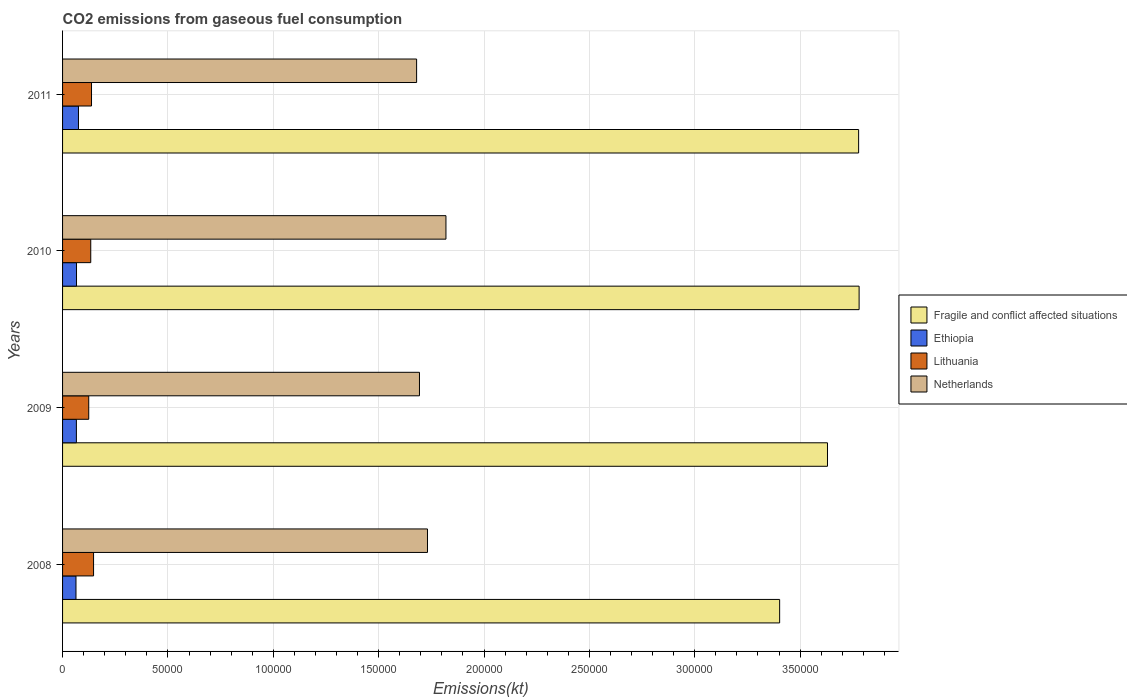How many groups of bars are there?
Offer a very short reply. 4. How many bars are there on the 2nd tick from the bottom?
Give a very brief answer. 4. What is the label of the 2nd group of bars from the top?
Provide a succinct answer. 2010. What is the amount of CO2 emitted in Fragile and conflict affected situations in 2010?
Ensure brevity in your answer.  3.78e+05. Across all years, what is the maximum amount of CO2 emitted in Lithuania?
Provide a succinct answer. 1.47e+04. Across all years, what is the minimum amount of CO2 emitted in Netherlands?
Ensure brevity in your answer.  1.68e+05. What is the total amount of CO2 emitted in Fragile and conflict affected situations in the graph?
Provide a short and direct response. 1.46e+06. What is the difference between the amount of CO2 emitted in Lithuania in 2010 and that in 2011?
Offer a terse response. -363.03. What is the difference between the amount of CO2 emitted in Ethiopia in 2009 and the amount of CO2 emitted in Lithuania in 2011?
Your answer should be very brief. -7179.99. What is the average amount of CO2 emitted in Ethiopia per year?
Make the answer very short. 6772.95. In the year 2011, what is the difference between the amount of CO2 emitted in Netherlands and amount of CO2 emitted in Fragile and conflict affected situations?
Give a very brief answer. -2.10e+05. What is the ratio of the amount of CO2 emitted in Lithuania in 2009 to that in 2011?
Give a very brief answer. 0.9. What is the difference between the highest and the second highest amount of CO2 emitted in Lithuania?
Offer a terse response. 968.09. What is the difference between the highest and the lowest amount of CO2 emitted in Fragile and conflict affected situations?
Keep it short and to the point. 3.77e+04. What does the 3rd bar from the top in 2010 represents?
Give a very brief answer. Ethiopia. Are all the bars in the graph horizontal?
Keep it short and to the point. Yes. Are the values on the major ticks of X-axis written in scientific E-notation?
Your response must be concise. No. Does the graph contain any zero values?
Offer a terse response. No. Does the graph contain grids?
Offer a very short reply. Yes. How many legend labels are there?
Ensure brevity in your answer.  4. How are the legend labels stacked?
Provide a short and direct response. Vertical. What is the title of the graph?
Keep it short and to the point. CO2 emissions from gaseous fuel consumption. Does "New Caledonia" appear as one of the legend labels in the graph?
Give a very brief answer. No. What is the label or title of the X-axis?
Keep it short and to the point. Emissions(kt). What is the Emissions(kt) of Fragile and conflict affected situations in 2008?
Provide a succinct answer. 3.40e+05. What is the Emissions(kt) in Ethiopia in 2008?
Your answer should be compact. 6369.58. What is the Emissions(kt) in Lithuania in 2008?
Provide a succinct answer. 1.47e+04. What is the Emissions(kt) in Netherlands in 2008?
Offer a terse response. 1.73e+05. What is the Emissions(kt) of Fragile and conflict affected situations in 2009?
Provide a succinct answer. 3.63e+05. What is the Emissions(kt) in Ethiopia in 2009?
Your answer should be very brief. 6560.26. What is the Emissions(kt) in Lithuania in 2009?
Ensure brevity in your answer.  1.24e+04. What is the Emissions(kt) in Netherlands in 2009?
Keep it short and to the point. 1.69e+05. What is the Emissions(kt) of Fragile and conflict affected situations in 2010?
Offer a very short reply. 3.78e+05. What is the Emissions(kt) of Ethiopia in 2010?
Ensure brevity in your answer.  6618.94. What is the Emissions(kt) in Lithuania in 2010?
Offer a very short reply. 1.34e+04. What is the Emissions(kt) in Netherlands in 2010?
Make the answer very short. 1.82e+05. What is the Emissions(kt) of Fragile and conflict affected situations in 2011?
Your answer should be very brief. 3.78e+05. What is the Emissions(kt) of Ethiopia in 2011?
Provide a succinct answer. 7543.02. What is the Emissions(kt) in Lithuania in 2011?
Ensure brevity in your answer.  1.37e+04. What is the Emissions(kt) of Netherlands in 2011?
Give a very brief answer. 1.68e+05. Across all years, what is the maximum Emissions(kt) in Fragile and conflict affected situations?
Provide a short and direct response. 3.78e+05. Across all years, what is the maximum Emissions(kt) in Ethiopia?
Your response must be concise. 7543.02. Across all years, what is the maximum Emissions(kt) of Lithuania?
Offer a terse response. 1.47e+04. Across all years, what is the maximum Emissions(kt) in Netherlands?
Ensure brevity in your answer.  1.82e+05. Across all years, what is the minimum Emissions(kt) of Fragile and conflict affected situations?
Ensure brevity in your answer.  3.40e+05. Across all years, what is the minimum Emissions(kt) in Ethiopia?
Your response must be concise. 6369.58. Across all years, what is the minimum Emissions(kt) in Lithuania?
Offer a terse response. 1.24e+04. Across all years, what is the minimum Emissions(kt) in Netherlands?
Keep it short and to the point. 1.68e+05. What is the total Emissions(kt) in Fragile and conflict affected situations in the graph?
Give a very brief answer. 1.46e+06. What is the total Emissions(kt) in Ethiopia in the graph?
Your response must be concise. 2.71e+04. What is the total Emissions(kt) in Lithuania in the graph?
Keep it short and to the point. 5.42e+04. What is the total Emissions(kt) in Netherlands in the graph?
Your answer should be compact. 6.92e+05. What is the difference between the Emissions(kt) in Fragile and conflict affected situations in 2008 and that in 2009?
Give a very brief answer. -2.27e+04. What is the difference between the Emissions(kt) of Ethiopia in 2008 and that in 2009?
Provide a succinct answer. -190.68. What is the difference between the Emissions(kt) in Lithuania in 2008 and that in 2009?
Your answer should be very brief. 2291.88. What is the difference between the Emissions(kt) in Netherlands in 2008 and that in 2009?
Provide a succinct answer. 3799.01. What is the difference between the Emissions(kt) of Fragile and conflict affected situations in 2008 and that in 2010?
Your answer should be very brief. -3.77e+04. What is the difference between the Emissions(kt) of Ethiopia in 2008 and that in 2010?
Offer a very short reply. -249.36. What is the difference between the Emissions(kt) in Lithuania in 2008 and that in 2010?
Your response must be concise. 1331.12. What is the difference between the Emissions(kt) in Netherlands in 2008 and that in 2010?
Give a very brief answer. -8764.13. What is the difference between the Emissions(kt) in Fragile and conflict affected situations in 2008 and that in 2011?
Ensure brevity in your answer.  -3.75e+04. What is the difference between the Emissions(kt) in Ethiopia in 2008 and that in 2011?
Provide a short and direct response. -1173.44. What is the difference between the Emissions(kt) of Lithuania in 2008 and that in 2011?
Make the answer very short. 968.09. What is the difference between the Emissions(kt) of Netherlands in 2008 and that in 2011?
Keep it short and to the point. 5155.8. What is the difference between the Emissions(kt) in Fragile and conflict affected situations in 2009 and that in 2010?
Give a very brief answer. -1.50e+04. What is the difference between the Emissions(kt) in Ethiopia in 2009 and that in 2010?
Ensure brevity in your answer.  -58.67. What is the difference between the Emissions(kt) in Lithuania in 2009 and that in 2010?
Give a very brief answer. -960.75. What is the difference between the Emissions(kt) of Netherlands in 2009 and that in 2010?
Ensure brevity in your answer.  -1.26e+04. What is the difference between the Emissions(kt) in Fragile and conflict affected situations in 2009 and that in 2011?
Ensure brevity in your answer.  -1.48e+04. What is the difference between the Emissions(kt) of Ethiopia in 2009 and that in 2011?
Give a very brief answer. -982.76. What is the difference between the Emissions(kt) in Lithuania in 2009 and that in 2011?
Provide a succinct answer. -1323.79. What is the difference between the Emissions(kt) of Netherlands in 2009 and that in 2011?
Offer a very short reply. 1356.79. What is the difference between the Emissions(kt) of Fragile and conflict affected situations in 2010 and that in 2011?
Offer a very short reply. 227.42. What is the difference between the Emissions(kt) in Ethiopia in 2010 and that in 2011?
Provide a succinct answer. -924.08. What is the difference between the Emissions(kt) of Lithuania in 2010 and that in 2011?
Your answer should be compact. -363.03. What is the difference between the Emissions(kt) of Netherlands in 2010 and that in 2011?
Make the answer very short. 1.39e+04. What is the difference between the Emissions(kt) of Fragile and conflict affected situations in 2008 and the Emissions(kt) of Ethiopia in 2009?
Ensure brevity in your answer.  3.34e+05. What is the difference between the Emissions(kt) in Fragile and conflict affected situations in 2008 and the Emissions(kt) in Lithuania in 2009?
Give a very brief answer. 3.28e+05. What is the difference between the Emissions(kt) in Fragile and conflict affected situations in 2008 and the Emissions(kt) in Netherlands in 2009?
Make the answer very short. 1.71e+05. What is the difference between the Emissions(kt) in Ethiopia in 2008 and the Emissions(kt) in Lithuania in 2009?
Provide a succinct answer. -6046.88. What is the difference between the Emissions(kt) of Ethiopia in 2008 and the Emissions(kt) of Netherlands in 2009?
Keep it short and to the point. -1.63e+05. What is the difference between the Emissions(kt) of Lithuania in 2008 and the Emissions(kt) of Netherlands in 2009?
Provide a succinct answer. -1.55e+05. What is the difference between the Emissions(kt) in Fragile and conflict affected situations in 2008 and the Emissions(kt) in Ethiopia in 2010?
Keep it short and to the point. 3.34e+05. What is the difference between the Emissions(kt) in Fragile and conflict affected situations in 2008 and the Emissions(kt) in Lithuania in 2010?
Make the answer very short. 3.27e+05. What is the difference between the Emissions(kt) of Fragile and conflict affected situations in 2008 and the Emissions(kt) of Netherlands in 2010?
Give a very brief answer. 1.58e+05. What is the difference between the Emissions(kt) in Ethiopia in 2008 and the Emissions(kt) in Lithuania in 2010?
Make the answer very short. -7007.64. What is the difference between the Emissions(kt) in Ethiopia in 2008 and the Emissions(kt) in Netherlands in 2010?
Provide a succinct answer. -1.76e+05. What is the difference between the Emissions(kt) of Lithuania in 2008 and the Emissions(kt) of Netherlands in 2010?
Give a very brief answer. -1.67e+05. What is the difference between the Emissions(kt) in Fragile and conflict affected situations in 2008 and the Emissions(kt) in Ethiopia in 2011?
Offer a terse response. 3.33e+05. What is the difference between the Emissions(kt) in Fragile and conflict affected situations in 2008 and the Emissions(kt) in Lithuania in 2011?
Provide a short and direct response. 3.27e+05. What is the difference between the Emissions(kt) in Fragile and conflict affected situations in 2008 and the Emissions(kt) in Netherlands in 2011?
Make the answer very short. 1.72e+05. What is the difference between the Emissions(kt) of Ethiopia in 2008 and the Emissions(kt) of Lithuania in 2011?
Keep it short and to the point. -7370.67. What is the difference between the Emissions(kt) in Ethiopia in 2008 and the Emissions(kt) in Netherlands in 2011?
Provide a short and direct response. -1.62e+05. What is the difference between the Emissions(kt) in Lithuania in 2008 and the Emissions(kt) in Netherlands in 2011?
Provide a short and direct response. -1.53e+05. What is the difference between the Emissions(kt) in Fragile and conflict affected situations in 2009 and the Emissions(kt) in Ethiopia in 2010?
Give a very brief answer. 3.56e+05. What is the difference between the Emissions(kt) in Fragile and conflict affected situations in 2009 and the Emissions(kt) in Lithuania in 2010?
Your answer should be compact. 3.50e+05. What is the difference between the Emissions(kt) in Fragile and conflict affected situations in 2009 and the Emissions(kt) in Netherlands in 2010?
Provide a short and direct response. 1.81e+05. What is the difference between the Emissions(kt) of Ethiopia in 2009 and the Emissions(kt) of Lithuania in 2010?
Ensure brevity in your answer.  -6816.95. What is the difference between the Emissions(kt) of Ethiopia in 2009 and the Emissions(kt) of Netherlands in 2010?
Make the answer very short. -1.75e+05. What is the difference between the Emissions(kt) of Lithuania in 2009 and the Emissions(kt) of Netherlands in 2010?
Your answer should be very brief. -1.70e+05. What is the difference between the Emissions(kt) of Fragile and conflict affected situations in 2009 and the Emissions(kt) of Ethiopia in 2011?
Provide a short and direct response. 3.55e+05. What is the difference between the Emissions(kt) of Fragile and conflict affected situations in 2009 and the Emissions(kt) of Lithuania in 2011?
Your answer should be very brief. 3.49e+05. What is the difference between the Emissions(kt) of Fragile and conflict affected situations in 2009 and the Emissions(kt) of Netherlands in 2011?
Your answer should be very brief. 1.95e+05. What is the difference between the Emissions(kt) of Ethiopia in 2009 and the Emissions(kt) of Lithuania in 2011?
Your answer should be very brief. -7179.99. What is the difference between the Emissions(kt) in Ethiopia in 2009 and the Emissions(kt) in Netherlands in 2011?
Your answer should be very brief. -1.61e+05. What is the difference between the Emissions(kt) of Lithuania in 2009 and the Emissions(kt) of Netherlands in 2011?
Your response must be concise. -1.56e+05. What is the difference between the Emissions(kt) in Fragile and conflict affected situations in 2010 and the Emissions(kt) in Ethiopia in 2011?
Your answer should be very brief. 3.70e+05. What is the difference between the Emissions(kt) in Fragile and conflict affected situations in 2010 and the Emissions(kt) in Lithuania in 2011?
Your answer should be very brief. 3.64e+05. What is the difference between the Emissions(kt) of Fragile and conflict affected situations in 2010 and the Emissions(kt) of Netherlands in 2011?
Offer a very short reply. 2.10e+05. What is the difference between the Emissions(kt) of Ethiopia in 2010 and the Emissions(kt) of Lithuania in 2011?
Ensure brevity in your answer.  -7121.31. What is the difference between the Emissions(kt) in Ethiopia in 2010 and the Emissions(kt) in Netherlands in 2011?
Your answer should be compact. -1.61e+05. What is the difference between the Emissions(kt) of Lithuania in 2010 and the Emissions(kt) of Netherlands in 2011?
Make the answer very short. -1.55e+05. What is the average Emissions(kt) of Fragile and conflict affected situations per year?
Your answer should be very brief. 3.65e+05. What is the average Emissions(kt) in Ethiopia per year?
Ensure brevity in your answer.  6772.95. What is the average Emissions(kt) in Lithuania per year?
Make the answer very short. 1.36e+04. What is the average Emissions(kt) in Netherlands per year?
Keep it short and to the point. 1.73e+05. In the year 2008, what is the difference between the Emissions(kt) of Fragile and conflict affected situations and Emissions(kt) of Ethiopia?
Provide a succinct answer. 3.34e+05. In the year 2008, what is the difference between the Emissions(kt) of Fragile and conflict affected situations and Emissions(kt) of Lithuania?
Offer a terse response. 3.26e+05. In the year 2008, what is the difference between the Emissions(kt) in Fragile and conflict affected situations and Emissions(kt) in Netherlands?
Provide a short and direct response. 1.67e+05. In the year 2008, what is the difference between the Emissions(kt) of Ethiopia and Emissions(kt) of Lithuania?
Give a very brief answer. -8338.76. In the year 2008, what is the difference between the Emissions(kt) in Ethiopia and Emissions(kt) in Netherlands?
Offer a terse response. -1.67e+05. In the year 2008, what is the difference between the Emissions(kt) of Lithuania and Emissions(kt) of Netherlands?
Your response must be concise. -1.58e+05. In the year 2009, what is the difference between the Emissions(kt) in Fragile and conflict affected situations and Emissions(kt) in Ethiopia?
Offer a very short reply. 3.56e+05. In the year 2009, what is the difference between the Emissions(kt) of Fragile and conflict affected situations and Emissions(kt) of Lithuania?
Ensure brevity in your answer.  3.51e+05. In the year 2009, what is the difference between the Emissions(kt) in Fragile and conflict affected situations and Emissions(kt) in Netherlands?
Provide a short and direct response. 1.94e+05. In the year 2009, what is the difference between the Emissions(kt) of Ethiopia and Emissions(kt) of Lithuania?
Your answer should be compact. -5856.2. In the year 2009, what is the difference between the Emissions(kt) of Ethiopia and Emissions(kt) of Netherlands?
Your answer should be compact. -1.63e+05. In the year 2009, what is the difference between the Emissions(kt) of Lithuania and Emissions(kt) of Netherlands?
Offer a very short reply. -1.57e+05. In the year 2010, what is the difference between the Emissions(kt) of Fragile and conflict affected situations and Emissions(kt) of Ethiopia?
Ensure brevity in your answer.  3.71e+05. In the year 2010, what is the difference between the Emissions(kt) of Fragile and conflict affected situations and Emissions(kt) of Lithuania?
Provide a succinct answer. 3.65e+05. In the year 2010, what is the difference between the Emissions(kt) in Fragile and conflict affected situations and Emissions(kt) in Netherlands?
Make the answer very short. 1.96e+05. In the year 2010, what is the difference between the Emissions(kt) of Ethiopia and Emissions(kt) of Lithuania?
Ensure brevity in your answer.  -6758.28. In the year 2010, what is the difference between the Emissions(kt) in Ethiopia and Emissions(kt) in Netherlands?
Your response must be concise. -1.75e+05. In the year 2010, what is the difference between the Emissions(kt) of Lithuania and Emissions(kt) of Netherlands?
Give a very brief answer. -1.69e+05. In the year 2011, what is the difference between the Emissions(kt) in Fragile and conflict affected situations and Emissions(kt) in Ethiopia?
Make the answer very short. 3.70e+05. In the year 2011, what is the difference between the Emissions(kt) of Fragile and conflict affected situations and Emissions(kt) of Lithuania?
Offer a terse response. 3.64e+05. In the year 2011, what is the difference between the Emissions(kt) in Fragile and conflict affected situations and Emissions(kt) in Netherlands?
Your answer should be very brief. 2.10e+05. In the year 2011, what is the difference between the Emissions(kt) in Ethiopia and Emissions(kt) in Lithuania?
Provide a succinct answer. -6197.23. In the year 2011, what is the difference between the Emissions(kt) of Ethiopia and Emissions(kt) of Netherlands?
Offer a terse response. -1.60e+05. In the year 2011, what is the difference between the Emissions(kt) of Lithuania and Emissions(kt) of Netherlands?
Offer a terse response. -1.54e+05. What is the ratio of the Emissions(kt) of Fragile and conflict affected situations in 2008 to that in 2009?
Offer a very short reply. 0.94. What is the ratio of the Emissions(kt) of Ethiopia in 2008 to that in 2009?
Give a very brief answer. 0.97. What is the ratio of the Emissions(kt) in Lithuania in 2008 to that in 2009?
Your answer should be very brief. 1.18. What is the ratio of the Emissions(kt) in Netherlands in 2008 to that in 2009?
Provide a succinct answer. 1.02. What is the ratio of the Emissions(kt) in Fragile and conflict affected situations in 2008 to that in 2010?
Provide a short and direct response. 0.9. What is the ratio of the Emissions(kt) of Ethiopia in 2008 to that in 2010?
Provide a short and direct response. 0.96. What is the ratio of the Emissions(kt) of Lithuania in 2008 to that in 2010?
Make the answer very short. 1.1. What is the ratio of the Emissions(kt) of Netherlands in 2008 to that in 2010?
Offer a terse response. 0.95. What is the ratio of the Emissions(kt) of Fragile and conflict affected situations in 2008 to that in 2011?
Make the answer very short. 0.9. What is the ratio of the Emissions(kt) of Ethiopia in 2008 to that in 2011?
Your response must be concise. 0.84. What is the ratio of the Emissions(kt) of Lithuania in 2008 to that in 2011?
Ensure brevity in your answer.  1.07. What is the ratio of the Emissions(kt) in Netherlands in 2008 to that in 2011?
Ensure brevity in your answer.  1.03. What is the ratio of the Emissions(kt) in Fragile and conflict affected situations in 2009 to that in 2010?
Your answer should be compact. 0.96. What is the ratio of the Emissions(kt) of Ethiopia in 2009 to that in 2010?
Offer a very short reply. 0.99. What is the ratio of the Emissions(kt) in Lithuania in 2009 to that in 2010?
Ensure brevity in your answer.  0.93. What is the ratio of the Emissions(kt) of Netherlands in 2009 to that in 2010?
Keep it short and to the point. 0.93. What is the ratio of the Emissions(kt) of Fragile and conflict affected situations in 2009 to that in 2011?
Provide a short and direct response. 0.96. What is the ratio of the Emissions(kt) of Ethiopia in 2009 to that in 2011?
Ensure brevity in your answer.  0.87. What is the ratio of the Emissions(kt) of Lithuania in 2009 to that in 2011?
Provide a succinct answer. 0.9. What is the ratio of the Emissions(kt) in Netherlands in 2009 to that in 2011?
Keep it short and to the point. 1.01. What is the ratio of the Emissions(kt) in Fragile and conflict affected situations in 2010 to that in 2011?
Provide a short and direct response. 1. What is the ratio of the Emissions(kt) in Ethiopia in 2010 to that in 2011?
Your answer should be very brief. 0.88. What is the ratio of the Emissions(kt) of Lithuania in 2010 to that in 2011?
Give a very brief answer. 0.97. What is the ratio of the Emissions(kt) of Netherlands in 2010 to that in 2011?
Offer a very short reply. 1.08. What is the difference between the highest and the second highest Emissions(kt) in Fragile and conflict affected situations?
Your response must be concise. 227.42. What is the difference between the highest and the second highest Emissions(kt) in Ethiopia?
Your response must be concise. 924.08. What is the difference between the highest and the second highest Emissions(kt) in Lithuania?
Your answer should be very brief. 968.09. What is the difference between the highest and the second highest Emissions(kt) in Netherlands?
Your response must be concise. 8764.13. What is the difference between the highest and the lowest Emissions(kt) of Fragile and conflict affected situations?
Give a very brief answer. 3.77e+04. What is the difference between the highest and the lowest Emissions(kt) in Ethiopia?
Offer a very short reply. 1173.44. What is the difference between the highest and the lowest Emissions(kt) of Lithuania?
Your response must be concise. 2291.88. What is the difference between the highest and the lowest Emissions(kt) of Netherlands?
Provide a succinct answer. 1.39e+04. 